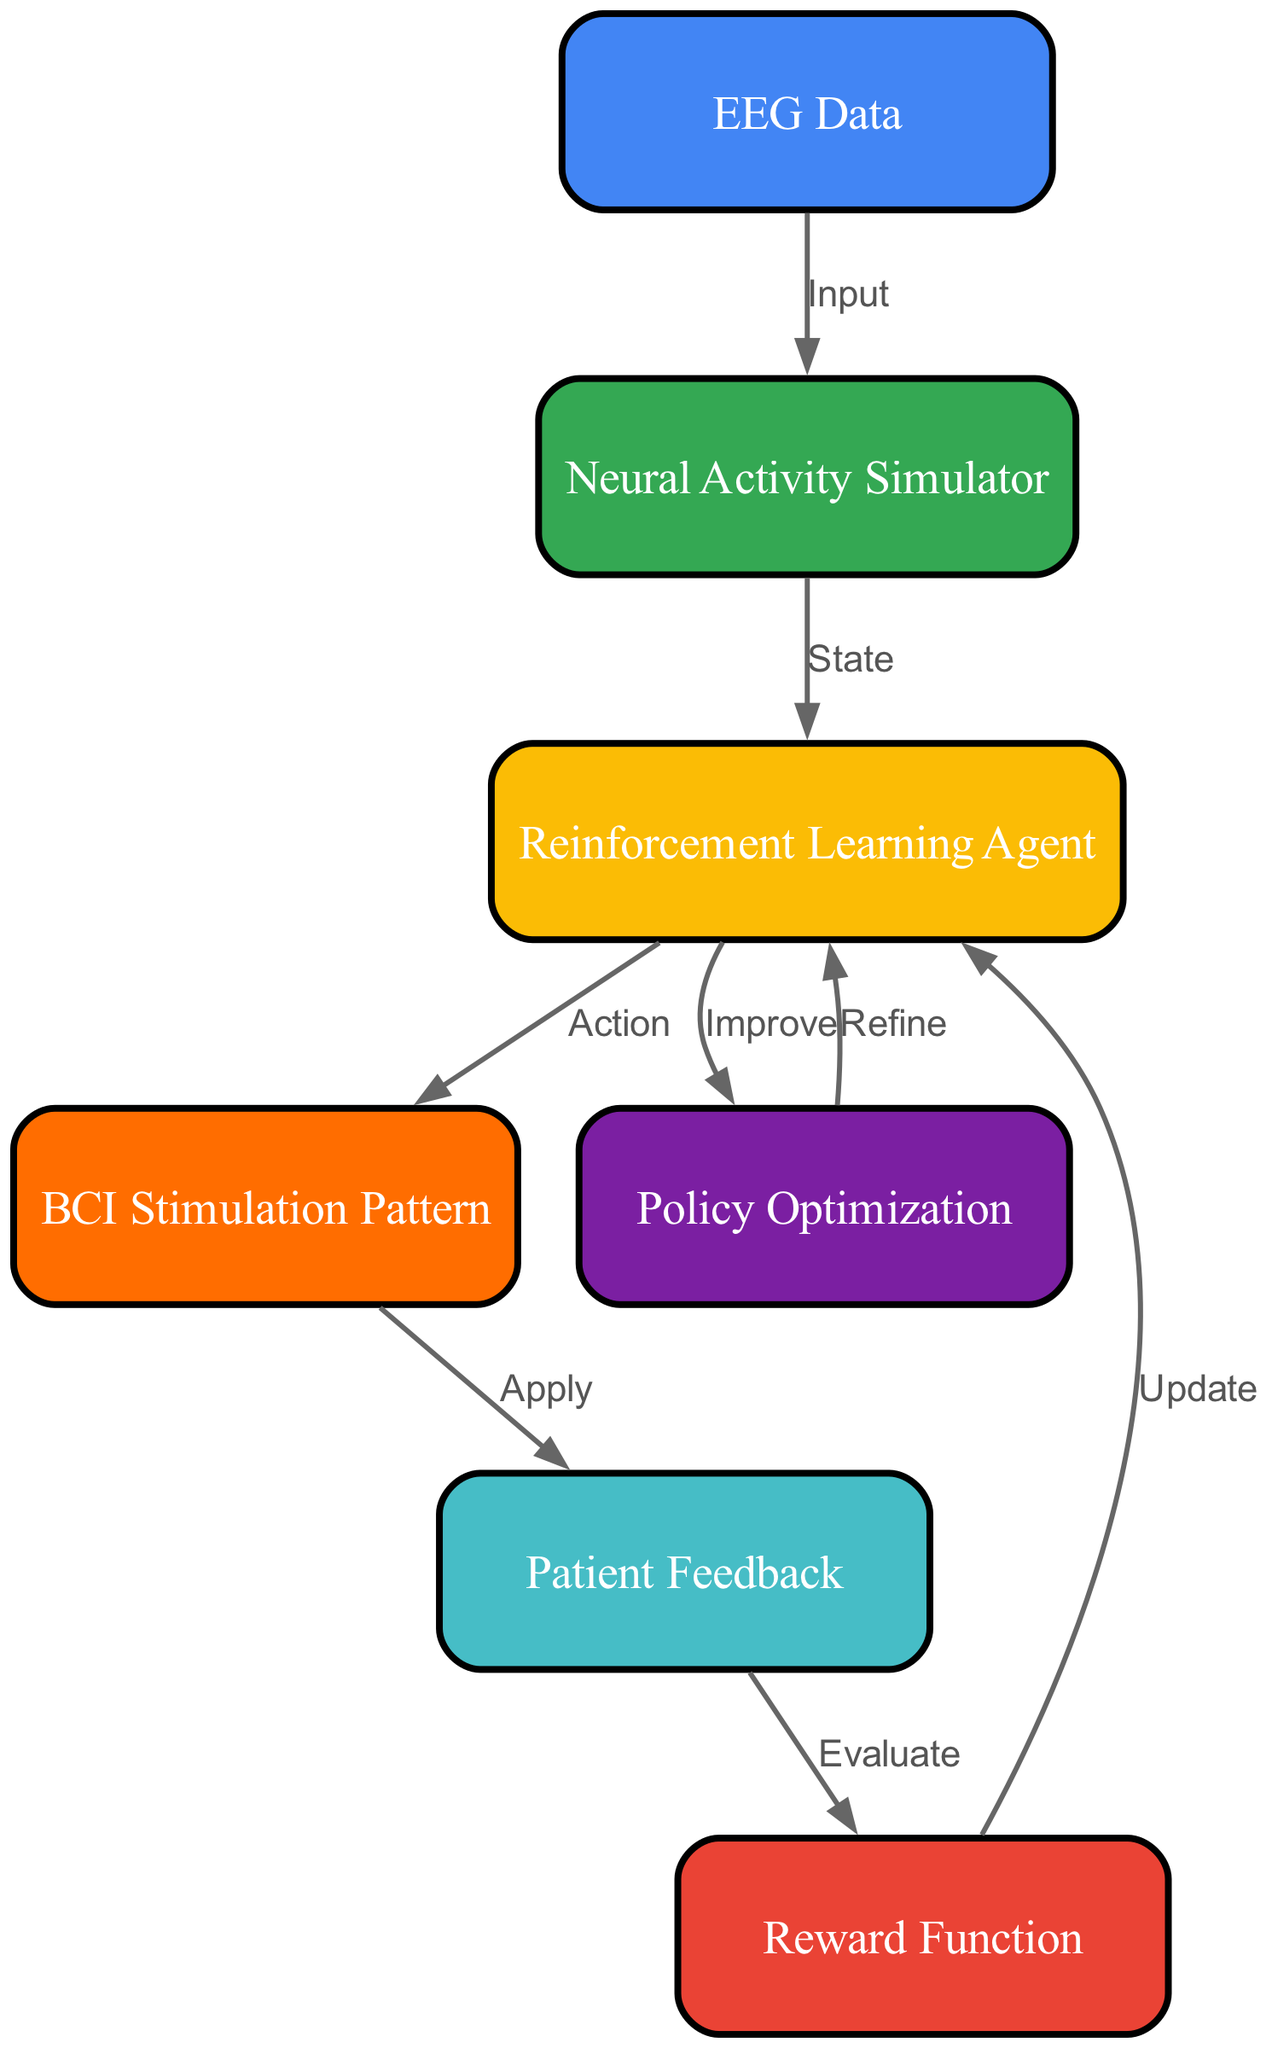What is the total number of nodes in the diagram? The diagram contains a total of 7 nodes which are "EEG Data", "Neural Activity Simulator", "Reinforcement Learning Agent", "Reward Function", "BCI Stimulation Pattern", "Patient Feedback", and "Policy Optimization".
Answer: 7 What is the function of the edge from "Neural Activity Simulator" to "Reinforcement Learning Agent"? The edge labeled "State" indicates that the "Neural Activity Simulator" provides the current state of the simulation to the "Reinforcement Learning Agent" for processing.
Answer: State Which node receives the output from the "BCI Stimulation Pattern"? The "Patient Feedback" node receives the output from the "BCI Stimulation Pattern" as indicated by the edge labeled "Apply".
Answer: Patient Feedback What does the "Reward Function" evaluate? The "Reward Function" evaluates the feedback provided by the "Patient Feedback" in order to determine the effectiveness of the stimulation pattern.
Answer: Feedback How does the "Reinforcement Learning Agent" improve its policy? The "Reinforcement Learning Agent" improves its policy by utilizing the feedback loop between the "Reward Function" and "Policy Optimization" to refine its actions taken based on input states.
Answer: Policy Optimization What is the relationship between "Reward Function" and "Reinforcement Learning Agent"? The relationship is that the "Reward Function" provides updates to the "Reinforcement Learning Agent", allowing it to adjust its behavior based on the evaluated rewards.
Answer: Update Which node is the starting point for data input in the diagram? The "EEG Data" node serves as the starting point for data input, directing data into the "Neural Activity Simulator".
Answer: EEG Data What action does the "Reinforcement Learning Agent" take based on its state? The "Reinforcement Learning Agent" takes the action of selecting a "BCI Stimulation Pattern" based on the current state it receives from the "Neural Activity Simulator".
Answer: Action 